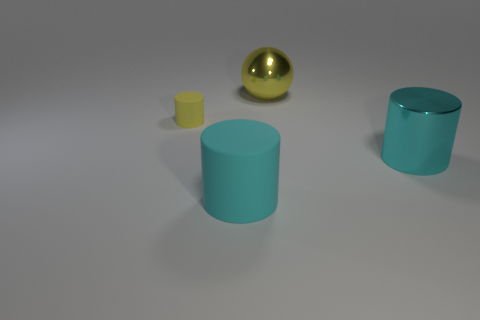Do the small thing and the large metallic cylinder have the same color?
Your answer should be compact. No. There is a small cylinder that is to the left of the large metallic thing in front of the small yellow thing; what is its material?
Your answer should be very brief. Rubber. What material is the other big cyan thing that is the same shape as the large cyan metal object?
Offer a very short reply. Rubber. There is a yellow object that is on the right side of the matte thing to the left of the cyan rubber thing; is there a big rubber object that is right of it?
Offer a terse response. No. How many other objects are there of the same color as the tiny thing?
Your answer should be very brief. 1. What number of objects are right of the yellow rubber thing and in front of the big yellow shiny sphere?
Your response must be concise. 2. What shape is the large cyan metallic object?
Your answer should be very brief. Cylinder. What number of other things are the same material as the yellow ball?
Give a very brief answer. 1. What is the color of the matte thing that is in front of the cyan object behind the matte object that is in front of the tiny yellow thing?
Your response must be concise. Cyan. What is the material of the other cyan cylinder that is the same size as the cyan metallic cylinder?
Provide a succinct answer. Rubber. 